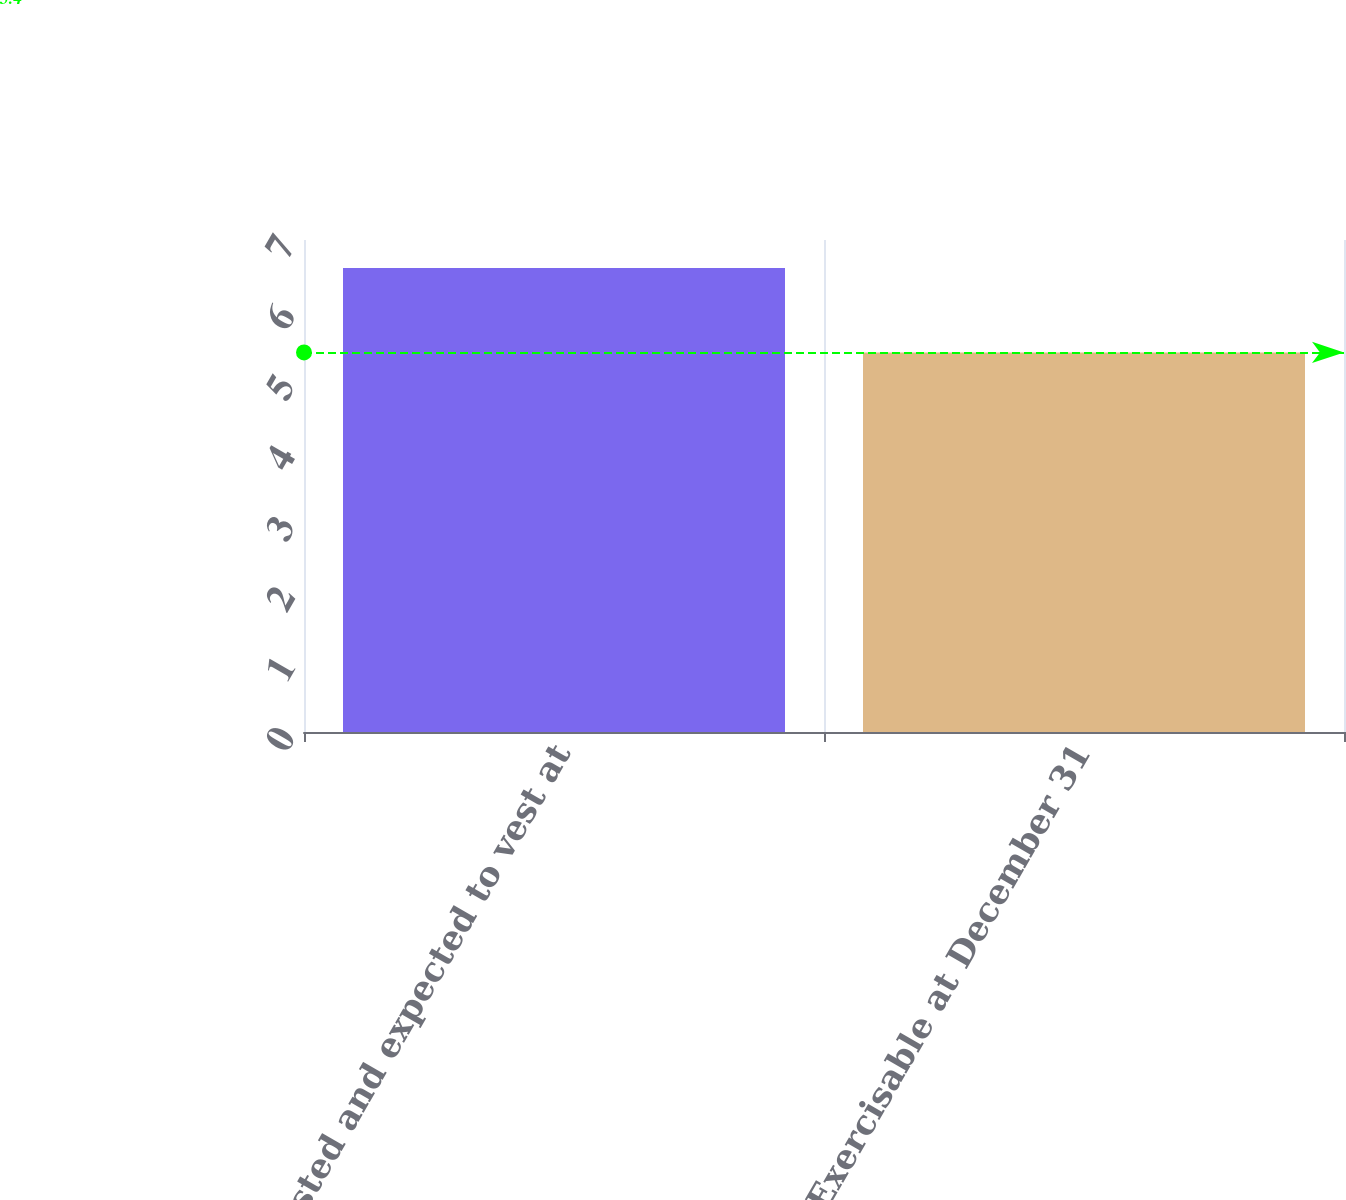Convert chart. <chart><loc_0><loc_0><loc_500><loc_500><bar_chart><fcel>Vested and expected to vest at<fcel>Exercisable at December 31<nl><fcel>6.6<fcel>5.4<nl></chart> 